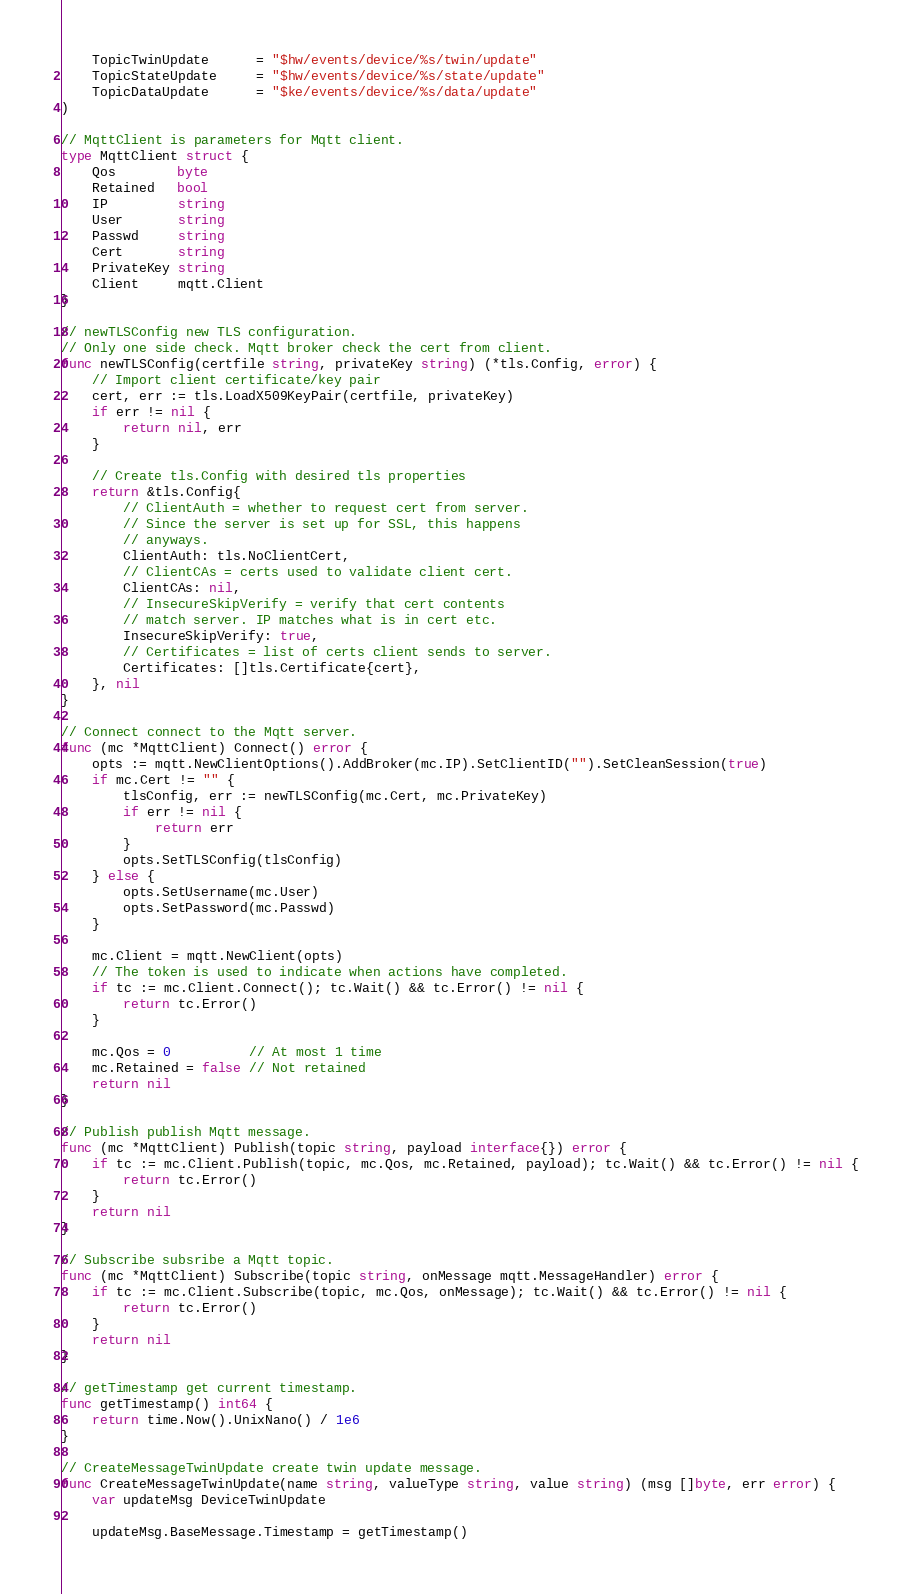<code> <loc_0><loc_0><loc_500><loc_500><_Go_>	TopicTwinUpdate      = "$hw/events/device/%s/twin/update"
	TopicStateUpdate     = "$hw/events/device/%s/state/update"
	TopicDataUpdate      = "$ke/events/device/%s/data/update"
)

// MqttClient is parameters for Mqtt client.
type MqttClient struct {
	Qos        byte
	Retained   bool
	IP         string
	User       string
	Passwd     string
	Cert       string
	PrivateKey string
	Client     mqtt.Client
}

// newTLSConfig new TLS configuration.
// Only one side check. Mqtt broker check the cert from client.
func newTLSConfig(certfile string, privateKey string) (*tls.Config, error) {
	// Import client certificate/key pair
	cert, err := tls.LoadX509KeyPair(certfile, privateKey)
	if err != nil {
		return nil, err
	}

	// Create tls.Config with desired tls properties
	return &tls.Config{
		// ClientAuth = whether to request cert from server.
		// Since the server is set up for SSL, this happens
		// anyways.
		ClientAuth: tls.NoClientCert,
		// ClientCAs = certs used to validate client cert.
		ClientCAs: nil,
		// InsecureSkipVerify = verify that cert contents
		// match server. IP matches what is in cert etc.
		InsecureSkipVerify: true,
		// Certificates = list of certs client sends to server.
		Certificates: []tls.Certificate{cert},
	}, nil
}

// Connect connect to the Mqtt server.
func (mc *MqttClient) Connect() error {
	opts := mqtt.NewClientOptions().AddBroker(mc.IP).SetClientID("").SetCleanSession(true)
	if mc.Cert != "" {
		tlsConfig, err := newTLSConfig(mc.Cert, mc.PrivateKey)
		if err != nil {
			return err
		}
		opts.SetTLSConfig(tlsConfig)
	} else {
		opts.SetUsername(mc.User)
		opts.SetPassword(mc.Passwd)
	}

	mc.Client = mqtt.NewClient(opts)
	// The token is used to indicate when actions have completed.
	if tc := mc.Client.Connect(); tc.Wait() && tc.Error() != nil {
		return tc.Error()
	}

	mc.Qos = 0          // At most 1 time
	mc.Retained = false // Not retained
	return nil
}

// Publish publish Mqtt message.
func (mc *MqttClient) Publish(topic string, payload interface{}) error {
	if tc := mc.Client.Publish(topic, mc.Qos, mc.Retained, payload); tc.Wait() && tc.Error() != nil {
		return tc.Error()
	}
	return nil
}

// Subscribe subsribe a Mqtt topic.
func (mc *MqttClient) Subscribe(topic string, onMessage mqtt.MessageHandler) error {
	if tc := mc.Client.Subscribe(topic, mc.Qos, onMessage); tc.Wait() && tc.Error() != nil {
		return tc.Error()
	}
	return nil
}

// getTimestamp get current timestamp.
func getTimestamp() int64 {
	return time.Now().UnixNano() / 1e6
}

// CreateMessageTwinUpdate create twin update message.
func CreateMessageTwinUpdate(name string, valueType string, value string) (msg []byte, err error) {
	var updateMsg DeviceTwinUpdate

	updateMsg.BaseMessage.Timestamp = getTimestamp()</code> 